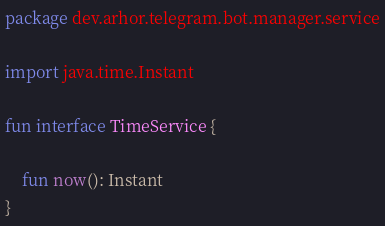<code> <loc_0><loc_0><loc_500><loc_500><_Kotlin_>package dev.arhor.telegram.bot.manager.service

import java.time.Instant

fun interface TimeService {

    fun now(): Instant
}</code> 